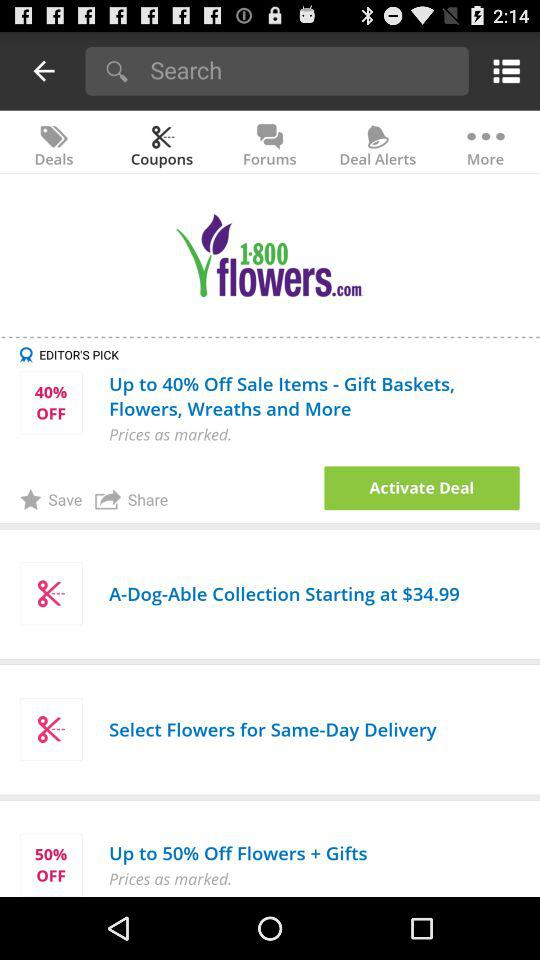On which items is the discount available? The discount is available on these items: "Gift Baskets,Flowers, Wreaths and More" and "Flowers + Gifts". 